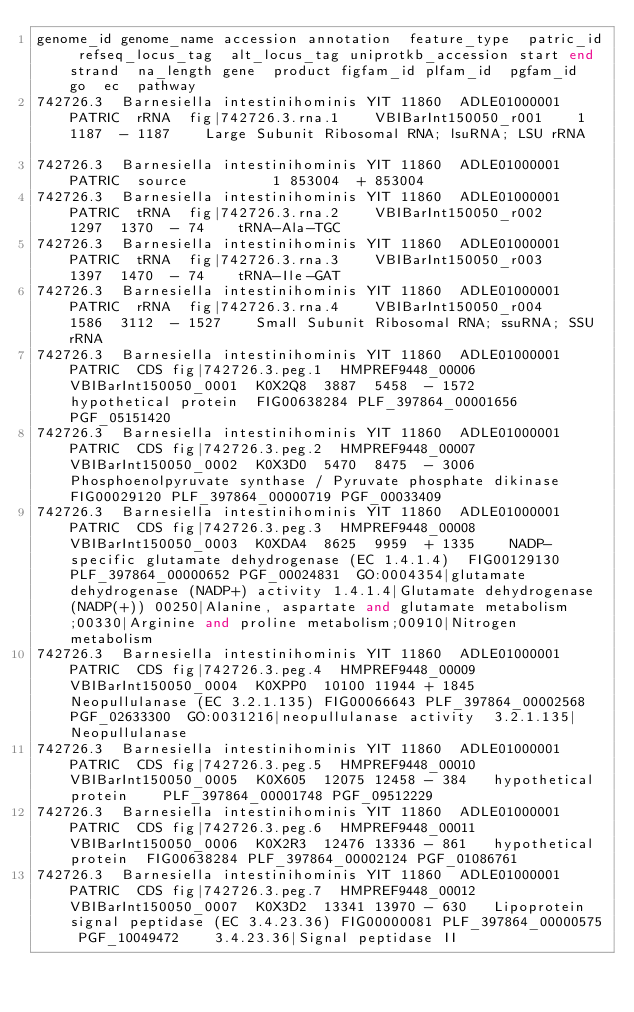Convert code to text. <code><loc_0><loc_0><loc_500><loc_500><_SQL_>genome_id	genome_name	accession	annotation	feature_type	patric_id	refseq_locus_tag	alt_locus_tag	uniprotkb_accession	start	end	strand	na_length	gene	product	figfam_id	plfam_id	pgfam_id	go	ec	pathway
742726.3	Barnesiella intestinihominis YIT 11860	ADLE01000001	PATRIC	rRNA	fig|742726.3.rna.1		VBIBarInt150050_r001		1	1187	-	1187		Large Subunit Ribosomal RNA; lsuRNA; LSU rRNA						
742726.3	Barnesiella intestinihominis YIT 11860	ADLE01000001	PATRIC	source					1	853004	+	853004								
742726.3	Barnesiella intestinihominis YIT 11860	ADLE01000001	PATRIC	tRNA	fig|742726.3.rna.2		VBIBarInt150050_r002		1297	1370	-	74		tRNA-Ala-TGC						
742726.3	Barnesiella intestinihominis YIT 11860	ADLE01000001	PATRIC	tRNA	fig|742726.3.rna.3		VBIBarInt150050_r003		1397	1470	-	74		tRNA-Ile-GAT						
742726.3	Barnesiella intestinihominis YIT 11860	ADLE01000001	PATRIC	rRNA	fig|742726.3.rna.4		VBIBarInt150050_r004		1586	3112	-	1527		Small Subunit Ribosomal RNA; ssuRNA; SSU rRNA						
742726.3	Barnesiella intestinihominis YIT 11860	ADLE01000001	PATRIC	CDS	fig|742726.3.peg.1	HMPREF9448_00006	VBIBarInt150050_0001	K0X2Q8	3887	5458	-	1572		hypothetical protein	FIG00638284	PLF_397864_00001656	PGF_05151420			
742726.3	Barnesiella intestinihominis YIT 11860	ADLE01000001	PATRIC	CDS	fig|742726.3.peg.2	HMPREF9448_00007	VBIBarInt150050_0002	K0X3D0	5470	8475	-	3006		Phosphoenolpyruvate synthase / Pyruvate phosphate dikinase	FIG00029120	PLF_397864_00000719	PGF_00033409			
742726.3	Barnesiella intestinihominis YIT 11860	ADLE01000001	PATRIC	CDS	fig|742726.3.peg.3	HMPREF9448_00008	VBIBarInt150050_0003	K0XDA4	8625	9959	+	1335		NADP-specific glutamate dehydrogenase (EC 1.4.1.4)	FIG00129130	PLF_397864_00000652	PGF_00024831	GO:0004354|glutamate dehydrogenase (NADP+) activity	1.4.1.4|Glutamate dehydrogenase (NADP(+))	00250|Alanine, aspartate and glutamate metabolism;00330|Arginine and proline metabolism;00910|Nitrogen metabolism
742726.3	Barnesiella intestinihominis YIT 11860	ADLE01000001	PATRIC	CDS	fig|742726.3.peg.4	HMPREF9448_00009	VBIBarInt150050_0004	K0XPP0	10100	11944	+	1845		Neopullulanase (EC 3.2.1.135)	FIG00066643	PLF_397864_00002568	PGF_02633300	GO:0031216|neopullulanase activity	3.2.1.135|Neopullulanase	
742726.3	Barnesiella intestinihominis YIT 11860	ADLE01000001	PATRIC	CDS	fig|742726.3.peg.5	HMPREF9448_00010	VBIBarInt150050_0005	K0X605	12075	12458	-	384		hypothetical protein		PLF_397864_00001748	PGF_09512229			
742726.3	Barnesiella intestinihominis YIT 11860	ADLE01000001	PATRIC	CDS	fig|742726.3.peg.6	HMPREF9448_00011	VBIBarInt150050_0006	K0X2R3	12476	13336	-	861		hypothetical protein	FIG00638284	PLF_397864_00002124	PGF_01086761			
742726.3	Barnesiella intestinihominis YIT 11860	ADLE01000001	PATRIC	CDS	fig|742726.3.peg.7	HMPREF9448_00012	VBIBarInt150050_0007	K0X3D2	13341	13970	-	630		Lipoprotein signal peptidase (EC 3.4.23.36)	FIG00000081	PLF_397864_00000575	PGF_10049472		3.4.23.36|Signal peptidase II	</code> 